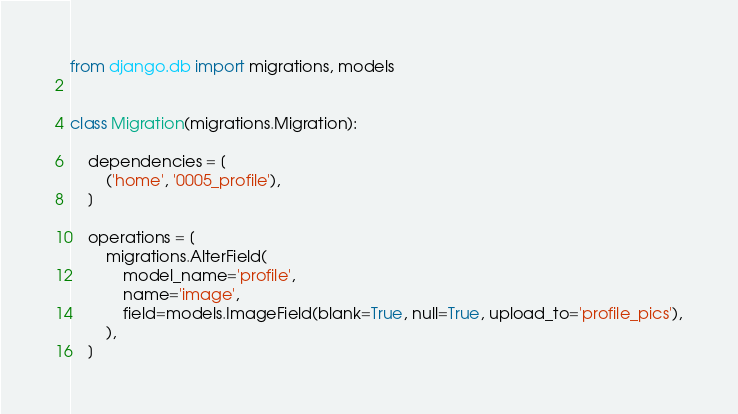Convert code to text. <code><loc_0><loc_0><loc_500><loc_500><_Python_>
from django.db import migrations, models


class Migration(migrations.Migration):

    dependencies = [
        ('home', '0005_profile'),
    ]

    operations = [
        migrations.AlterField(
            model_name='profile',
            name='image',
            field=models.ImageField(blank=True, null=True, upload_to='profile_pics'),
        ),
    ]
</code> 